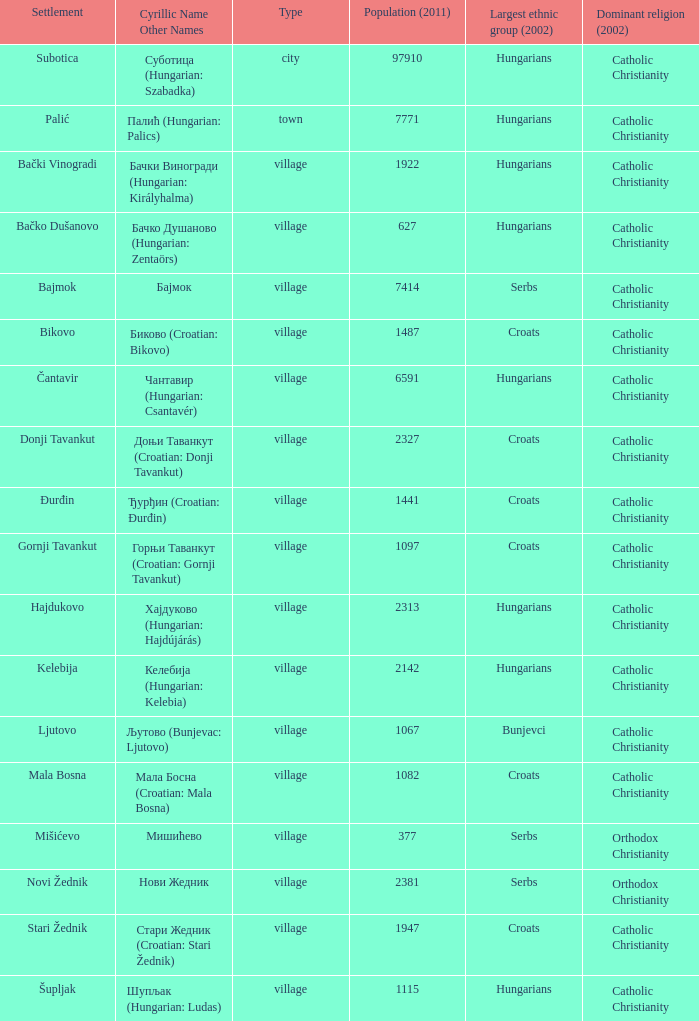What are the cyrillic and other names of the settlement whose population is 6591? Чантавир (Hungarian: Csantavér). 